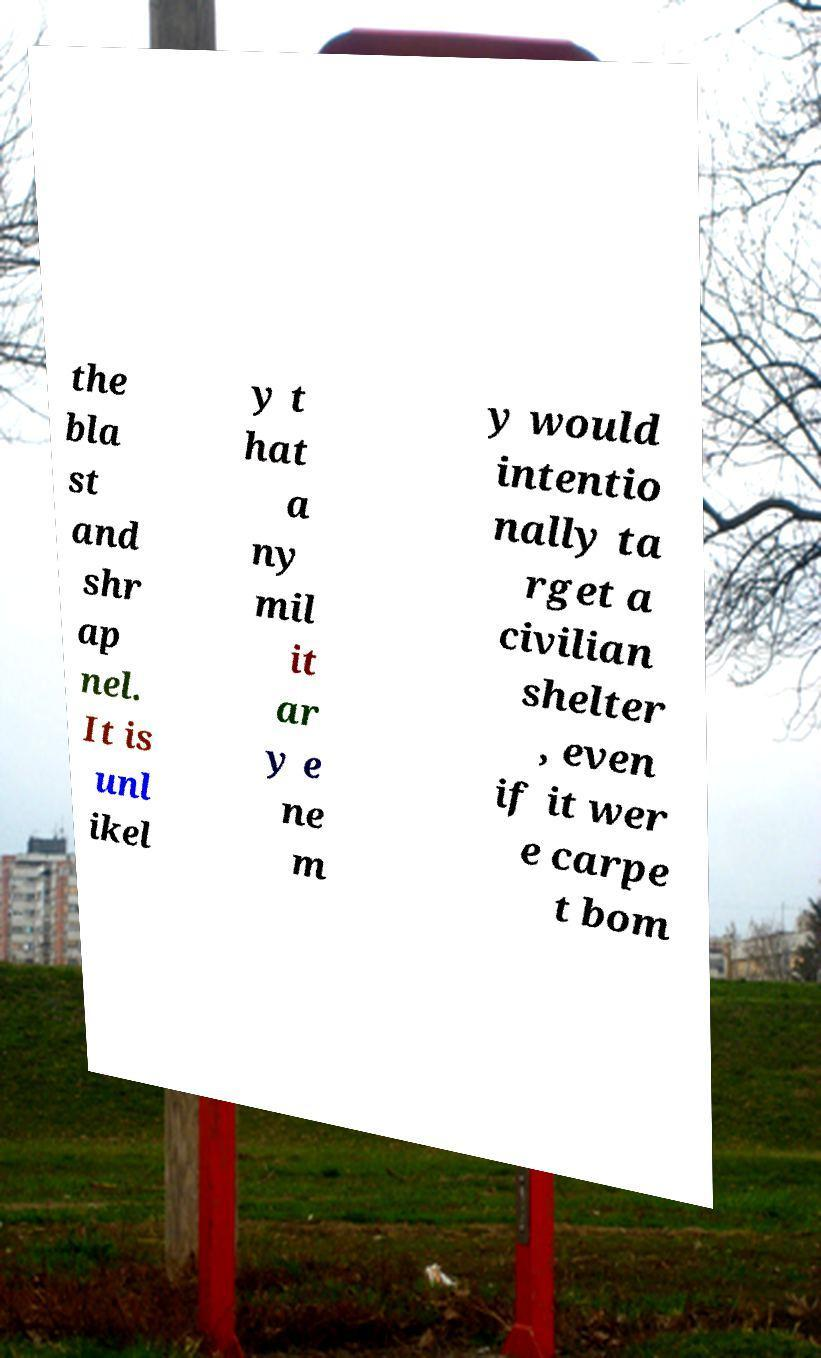There's text embedded in this image that I need extracted. Can you transcribe it verbatim? the bla st and shr ap nel. It is unl ikel y t hat a ny mil it ar y e ne m y would intentio nally ta rget a civilian shelter , even if it wer e carpe t bom 